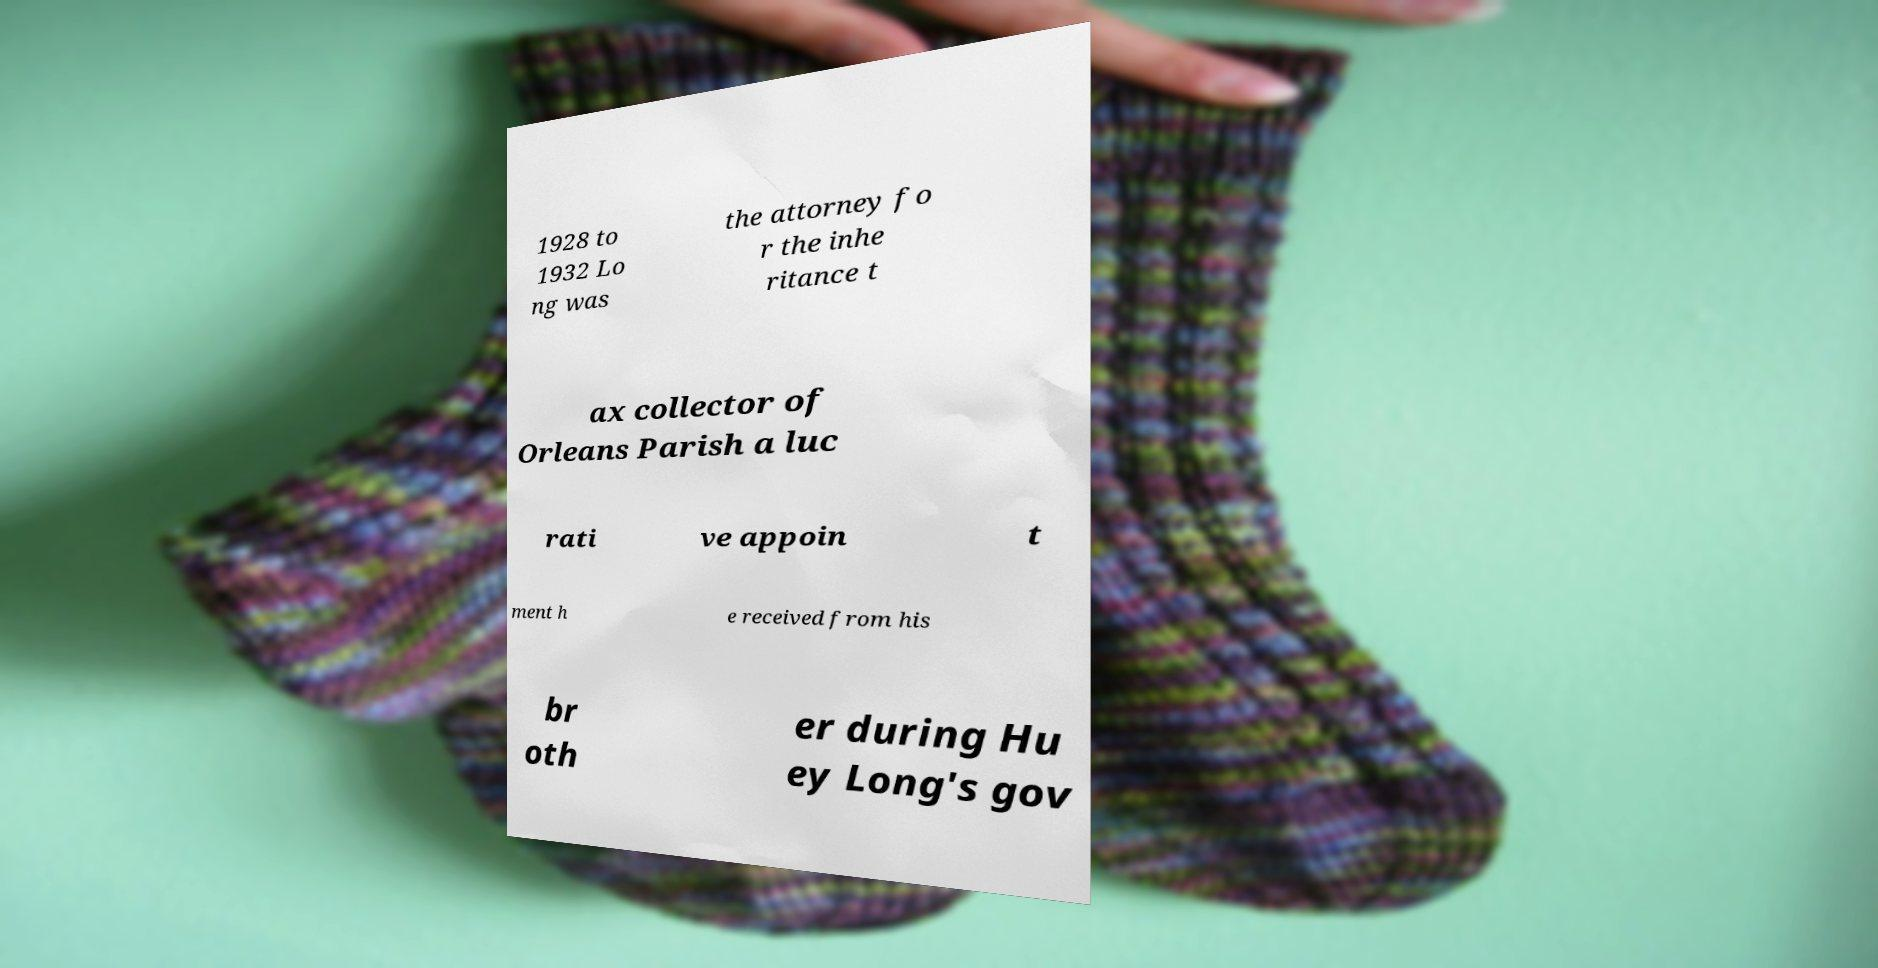Please identify and transcribe the text found in this image. 1928 to 1932 Lo ng was the attorney fo r the inhe ritance t ax collector of Orleans Parish a luc rati ve appoin t ment h e received from his br oth er during Hu ey Long's gov 